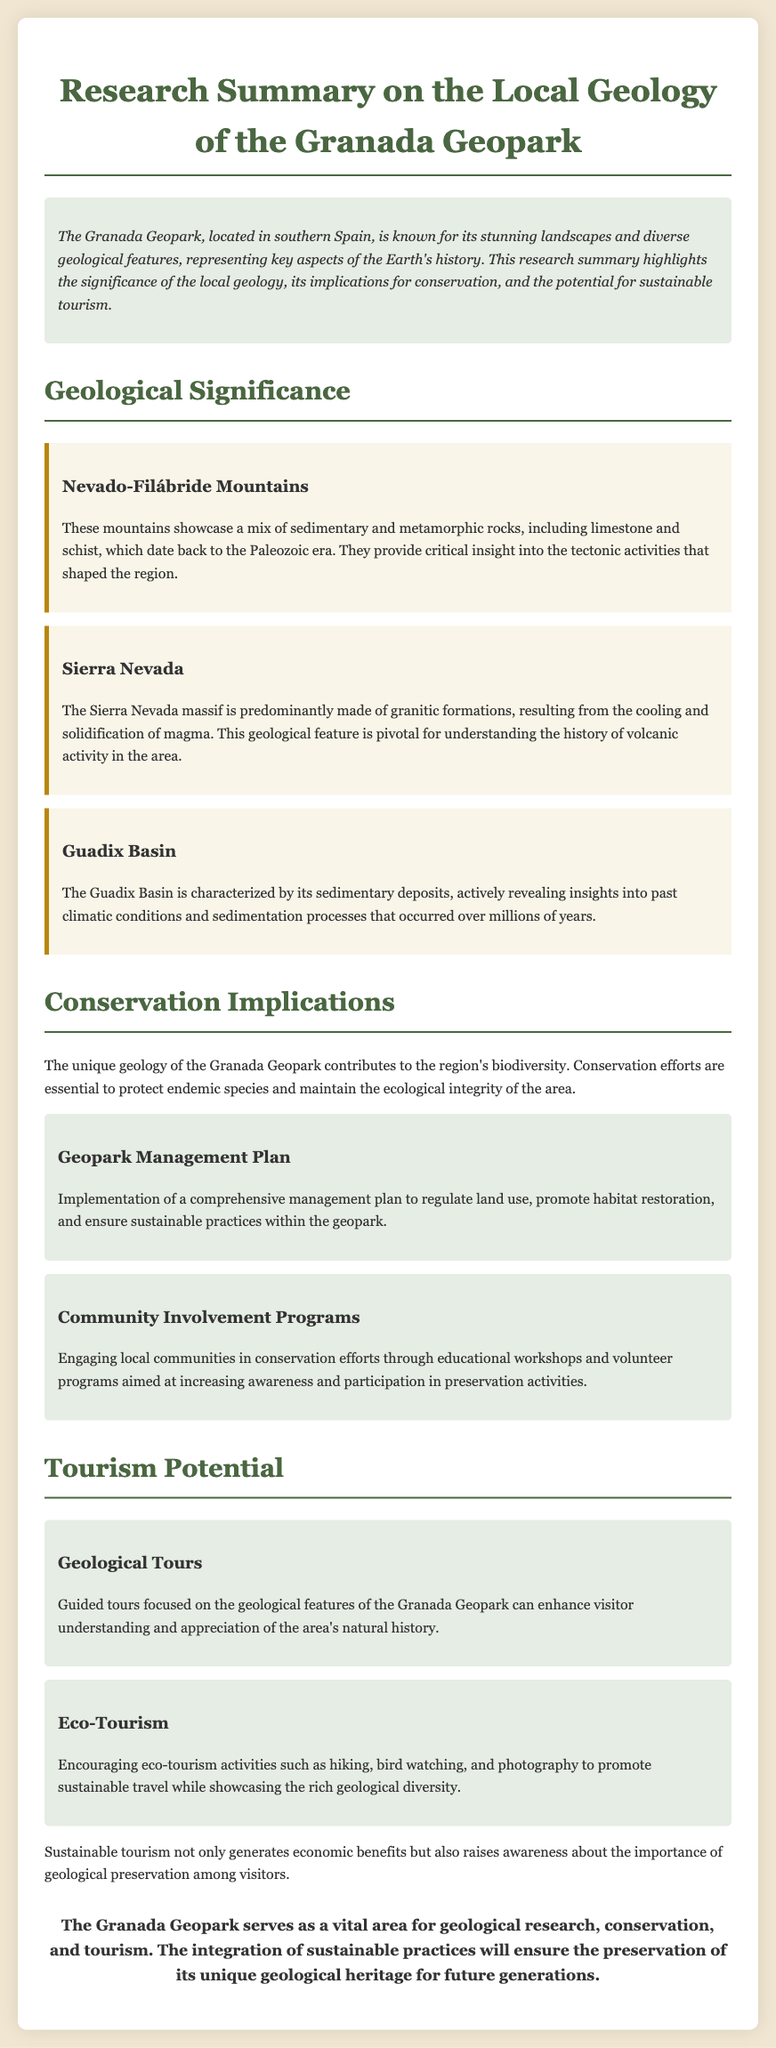What are the main geological features of the Granada Geopark? The main geological features include the Nevado-Filábride Mountains, Sierra Nevada, and Guadix Basin.
Answer: Nevado-Filábride Mountains, Sierra Nevada, Guadix Basin What type of rocks predominantly make up the Sierra Nevada? The Sierra Nevada is predominantly made of granitic formations resulting from volcanic activity.
Answer: Granitic formations What is one key aspect of the conservation implications in the document? The document mentions that conservation efforts are essential to protect endemic species and maintain ecological integrity.
Answer: Protect endemic species What is a component of the Geopark Management Plan? The Geopark Management Plan includes regulating land use and promoting habitat restoration.
Answer: Regulating land use What tourism activity is highlighted for enhancing visitor understanding? The document suggests geological tours focused on the features of the Granada Geopark enhance understanding.
Answer: Geological tours How does eco-tourism benefit the Granada Geopark? Eco-tourism activities help promote sustainable travel while showcasing geological diversity.
Answer: Promote sustainable travel What time period do the rocks in the Nevado-Filábride Mountains date back to? The rocks in the Nevado-Filábride Mountains date back to the Paleozoic era.
Answer: Paleozoic era What is the primary goal of community involvement programs? The primary goal is to increase awareness and participation in preservation activities.
Answer: Increase awareness What is the overall conclusion about the Granada Geopark? The conclusion emphasizes the importance of integrating sustainable practices for preservation.
Answer: Integrate sustainable practices 